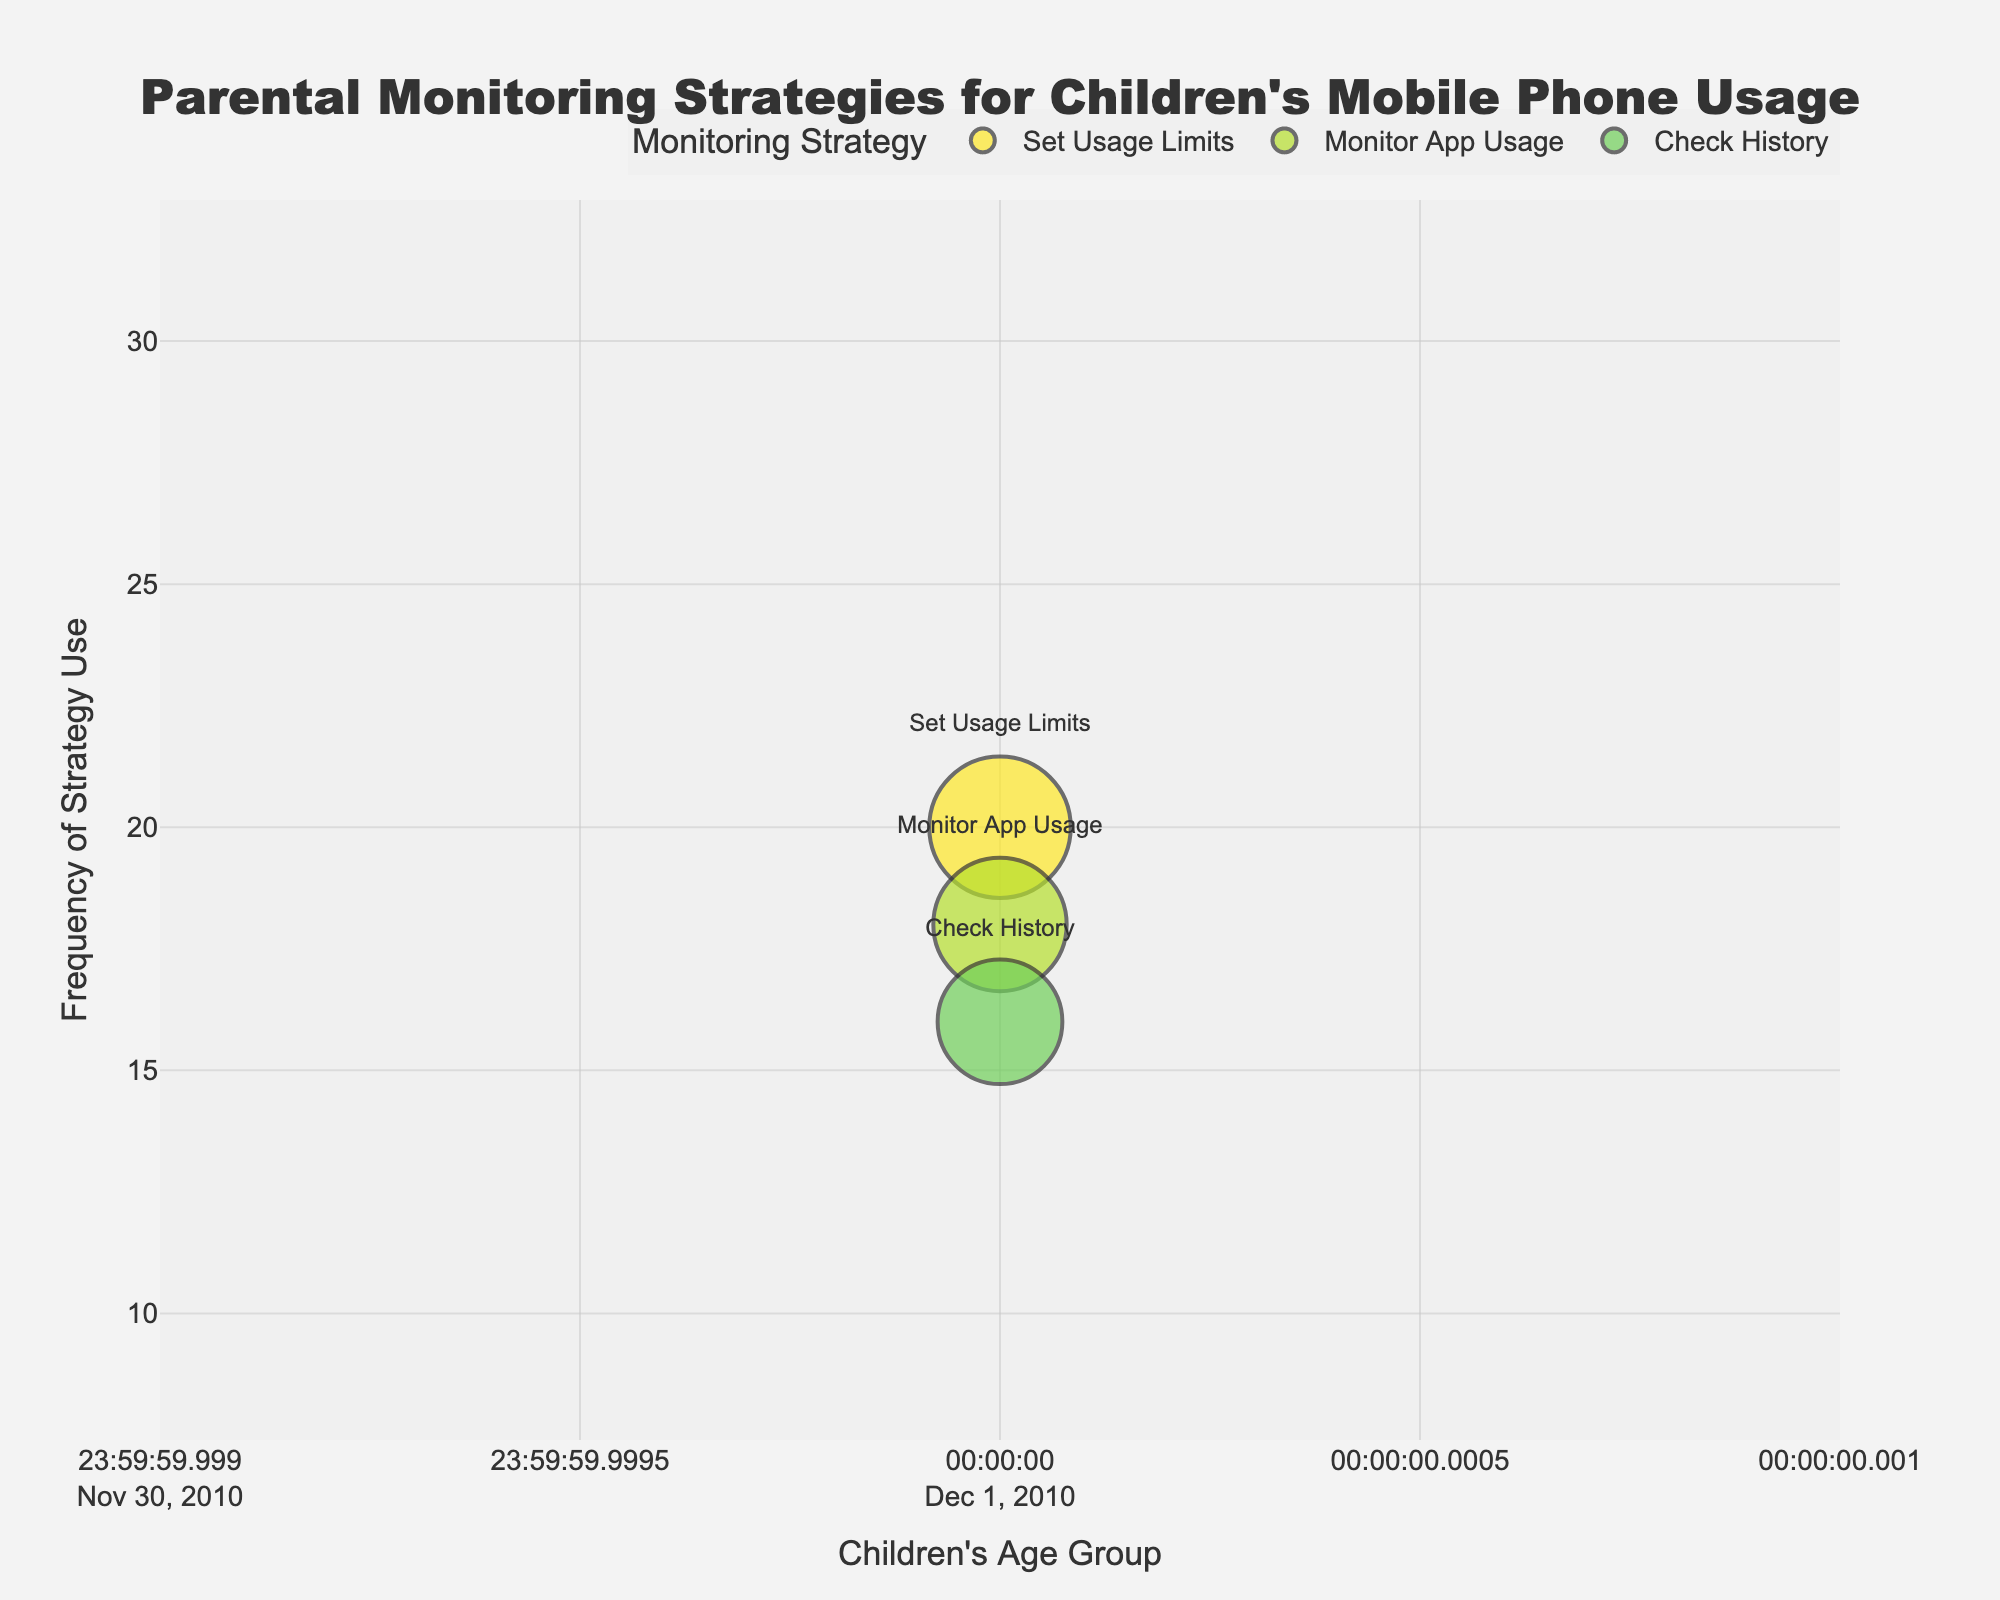How many strategies were monitored in the age group 7-9? To find the number of strategies monitored in the age group 7-9, look at the bubbles located along that age group on the x-axis. Count the number of distinct strategies.
Answer: 3 Which monitoring strategy has the highest frequency for children aged 13-15? To determine this, look for the largest bubble within the 13-15 age range along the x-axis and check the frequency value it represents on the y-axis. Then, identify the associated strategy.
Answer: Set Usage Limits What is the relationship between parent satisfaction and the size of the bubbles? In the bubble chart, the size of the bubbles represents "Parent Satisfaction." Larger bubbles indicate higher satisfaction.
Answer: Larger bubbles indicate higher satisfaction Compare the frequency of "Monitor App Usage" and "Check History" for children aged 10-12. Which has a higher frequency and by how much? Locate the bubbles representing "Monitor App Usage" and "Check History" within the 10-12 age group. Observe their respective frequencies. Subtract the frequency of "Check History" from "Monitor App Usage" to find the difference.
Answer: Monitor App Usage by 2 Which age group has the highest average parent satisfaction across all monitoring strategies? To determine the average parent satisfaction for each age group, sum the satisfaction scores for all strategies within each group and then divide by the number of strategies. Compare the averages to find the highest one.
Answer: 16-18 What trend do you notice in the frequency of "Set Usage Limits" as children age? Track the bubbles associated with "Set Usage Limits" across different age groups on the x-axis. Notice if the frequency increases, decreases, or remains the same as the children's age increases.
Answer: Increases How does the frequency of "Check History" change with children's age? Observe the position of "Check History" labeled bubbles across different age groups on the x-axis. Note how the frequency changes on the y-axis as the age increases.
Answer: Increases What is the total frequency of "Monitor App Usage" across all age groups? To find the total frequency of "Monitor App Usage," sum the frequencies of "Monitor App Usage" bubbles across each age group found on the y-axis.
Answer: 80 